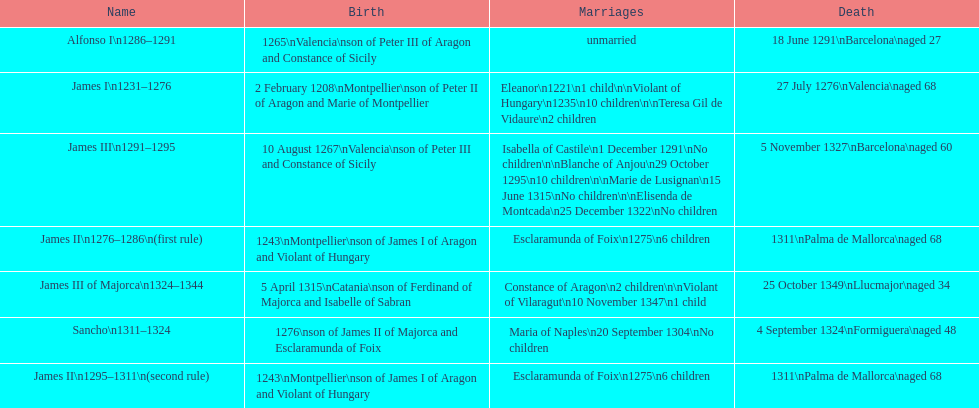Which monarch is listed first? James I 1231-1276. 